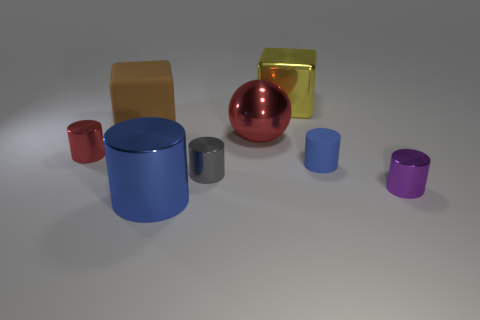Subtract all red cylinders. How many cylinders are left? 4 Subtract all rubber cylinders. How many cylinders are left? 4 Subtract all yellow cylinders. Subtract all green cubes. How many cylinders are left? 5 Add 1 big red matte balls. How many objects exist? 9 Subtract all balls. How many objects are left? 7 Add 1 blue rubber things. How many blue rubber things exist? 2 Subtract 0 gray balls. How many objects are left? 8 Subtract all large red shiny objects. Subtract all brown cubes. How many objects are left? 6 Add 2 tiny metallic objects. How many tiny metallic objects are left? 5 